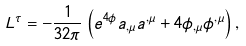Convert formula to latex. <formula><loc_0><loc_0><loc_500><loc_500>L ^ { \tau } = - \frac { 1 } { 3 2 \pi } \left ( e ^ { 4 \phi } a _ { , \mu } a ^ { , \mu } + 4 \phi _ { , \mu } \phi ^ { , \mu } \right ) ,</formula> 